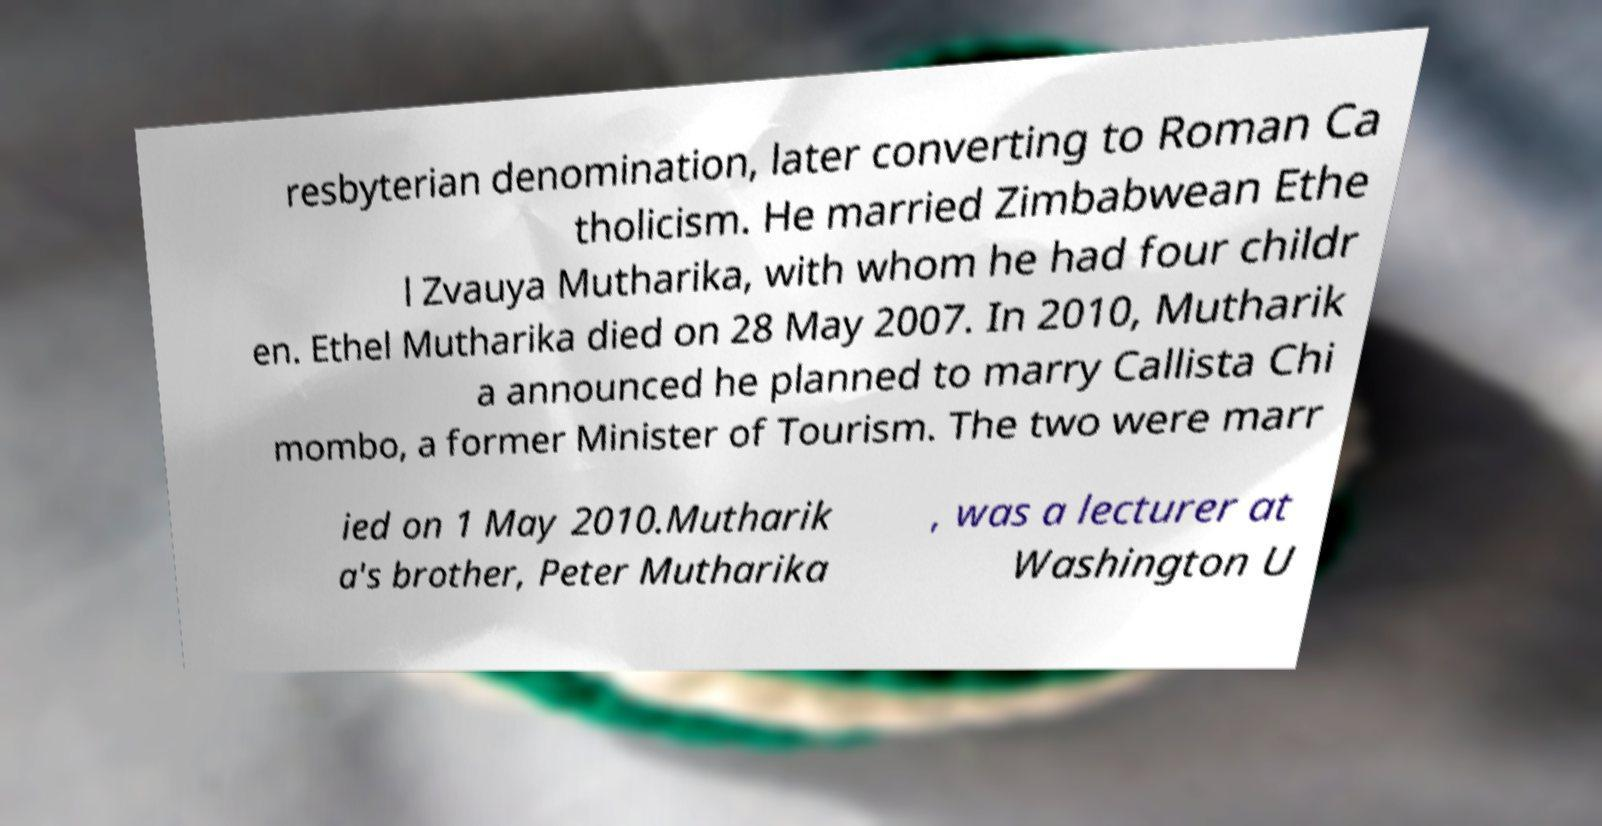For documentation purposes, I need the text within this image transcribed. Could you provide that? resbyterian denomination, later converting to Roman Ca tholicism. He married Zimbabwean Ethe l Zvauya Mutharika, with whom he had four childr en. Ethel Mutharika died on 28 May 2007. In 2010, Mutharik a announced he planned to marry Callista Chi mombo, a former Minister of Tourism. The two were marr ied on 1 May 2010.Mutharik a's brother, Peter Mutharika , was a lecturer at Washington U 